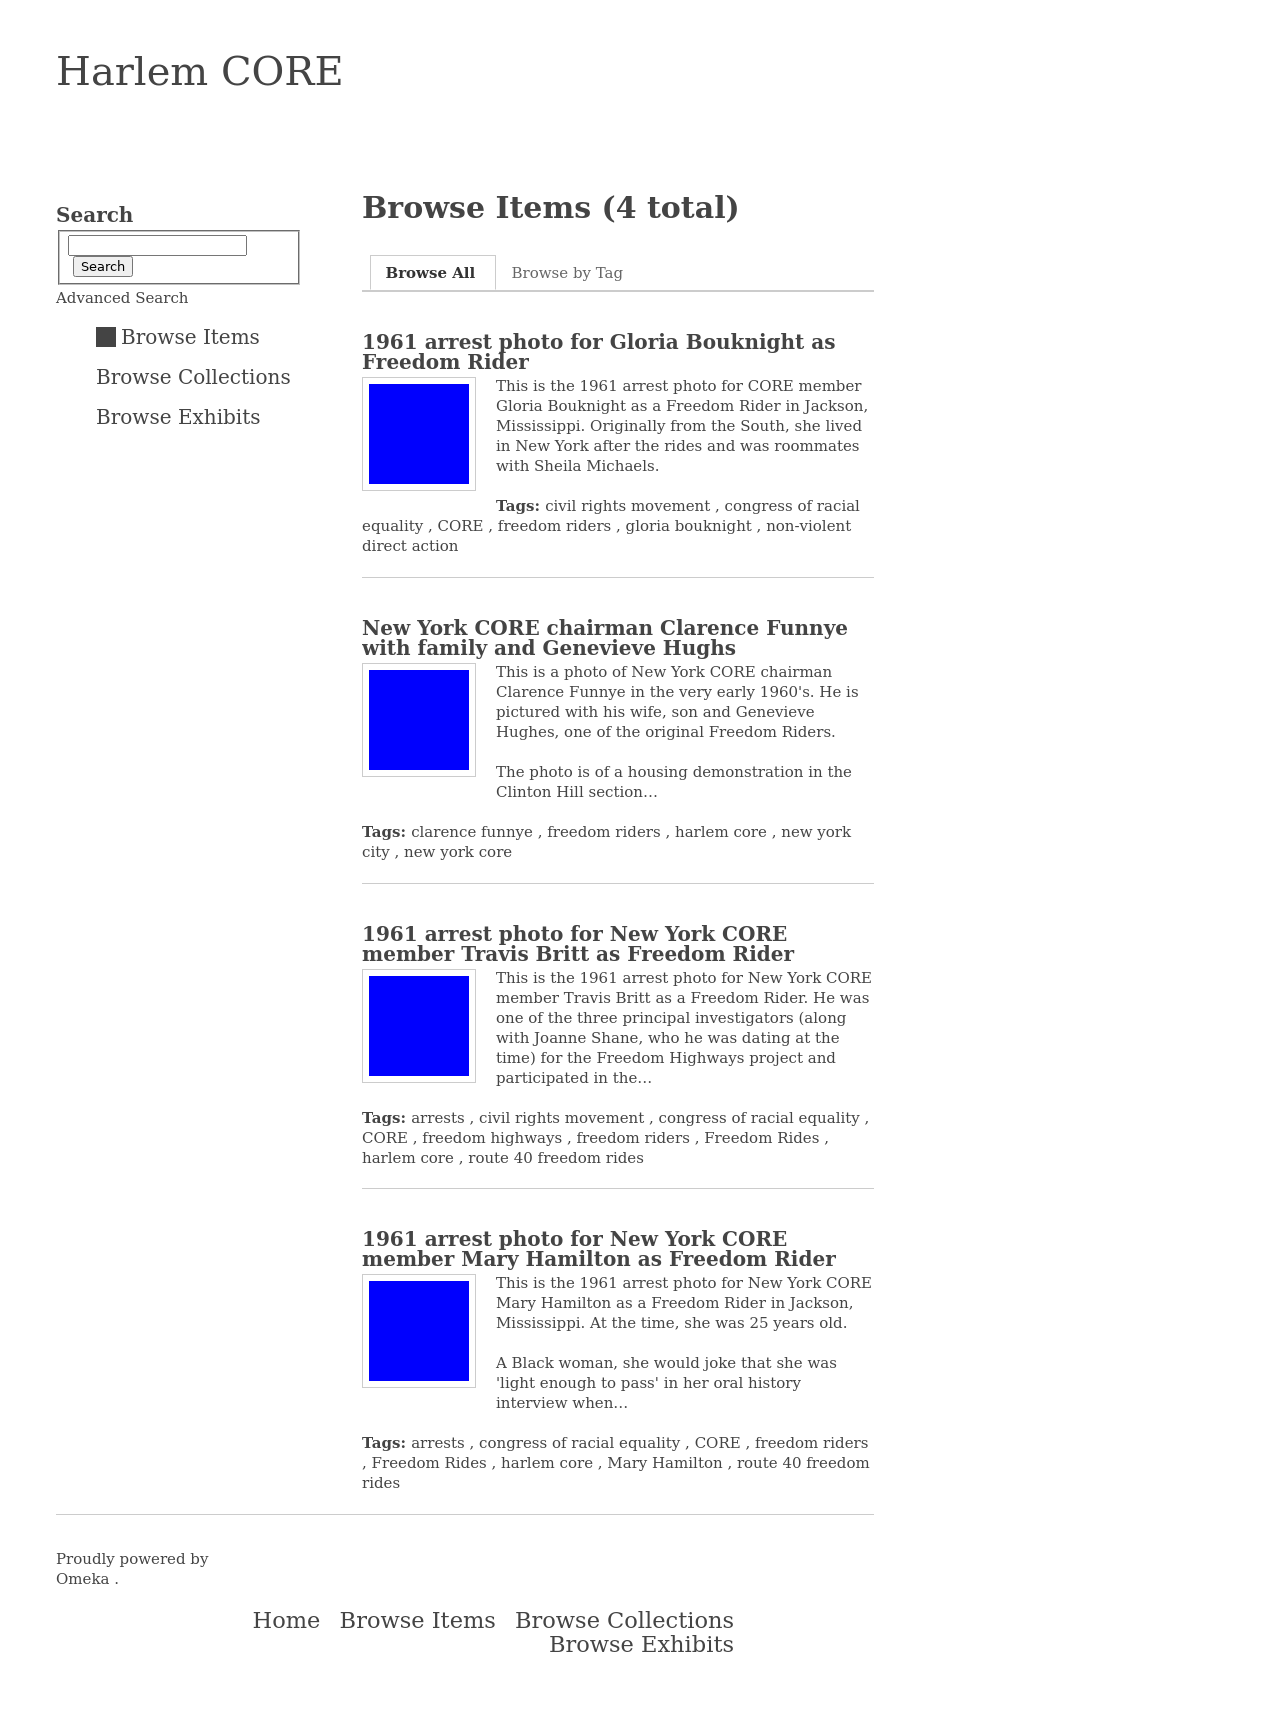Could you explain the significance of the housing demonstration in the Clinton Hill section mentioned in the caption? The housing demonstration mentioned likely refers to protests against discriminatory housing practices that were prevalent during the 1960s. Such demonstrations aimed to highlight racial inequality in housing, drawing attention to issues like redlining and segregation. The photo from the Clinton Hill section possibly represents an event where activists, including those from Harlem CORE and individuals like Clarence Funnye, took a stand for equal housing rights. These demonstrations were a crucial part of the civil rights movement, aiming to secure better living conditions and equality for African Americans. 